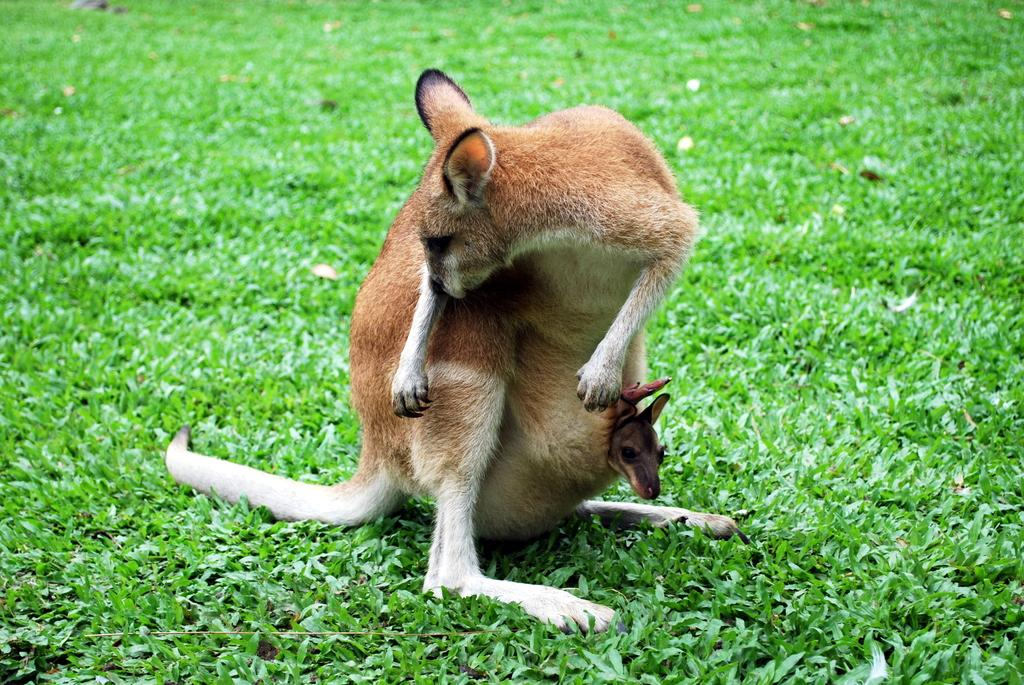What animal is the main subject of the image? There is a kangaroo in the image. Where is the kangaroo located? The kangaroo is on the grassland. Can you describe the kangaroo's family in the image? There is a baby kangaroo in the pouch of the kangaroo. What type of comb is the kangaroo using to groom its fur in the image? There is no comb present in the image; the kangaroo is not grooming its fur. 